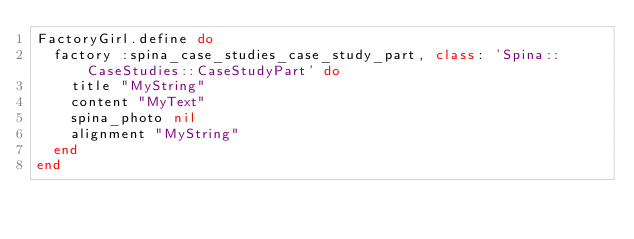<code> <loc_0><loc_0><loc_500><loc_500><_Ruby_>FactoryGirl.define do
  factory :spina_case_studies_case_study_part, class: 'Spina::CaseStudies::CaseStudyPart' do
    title "MyString"
    content "MyText"
    spina_photo nil
    alignment "MyString"
  end
end
</code> 